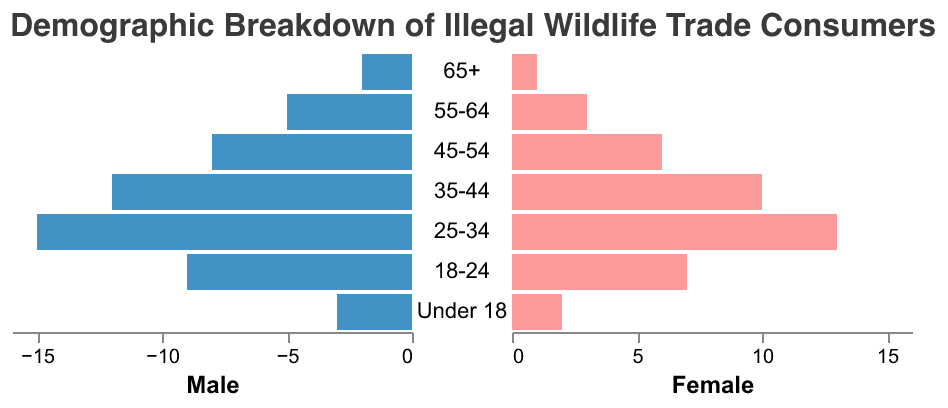What's the title of the figure? The title of the figure is displayed at the top of the plot.
Answer: Demographic Breakdown of Illegal Wildlife Trade Consumers What are the colors used to represent males and females in the chart? Males are represented by a blue color, and females are represented by a red (or pink) color.
Answer: Blue and Red Which age group has the highest number of male consumers? By comparing the length of the blue bars associated with each age group, the age group with the longest blue bar indicates the highest number.
Answer: 25-34 How many consumers are there in the 18-24 age group in total? Add the male and female consumers in the 18-24 age group. 9 (males) + 7 (females) = 16.
Answer: 16 What is the difference in the number of male and female consumers in the 35-44 age group? Subtract the number of female consumers from the number of male consumers in the 35-44 age group. 12 (males) - 10 (females) = 2.
Answer: 2 Which age group has the smallest number of female consumers? Identify the age group with the shortest red (or pink) bar.
Answer: 65+ What is the total number of male consumers across all age groups? Sum the number of male consumers in each age group: 2 + 5 + 8 + 12 + 15 + 9 + 3 = 54.
Answer: 54 Compare the total number of consumers in the 55-64 age group to the Under 18 age group. Which has more consumers? Calculate the totals for each age group: 55-64 (5 males + 3 females = 8); Under 18 (3 males + 2 females = 5). Thus, the 55-64 age group has more consumers.
Answer: 55-64 Are there more male or female consumers in the illegal wildlife trade market based on this chart? Calculate the total number of males and females across all age groups and compare them. Total males: 54, total females: 42. There are more males.
Answer: Males What's the combined percentage share of consumers aged 45-54 and 55-64? Add the number of consumers aged 45-54 (8 males + 6 females = 14) and aged 55-64 (5 males + 3 females = 8), and then divide by the total number of consumers (54 males + 42 females = 96). (14 + 8) / 96 * 100 = 22.92%.
Answer: 22.92% 